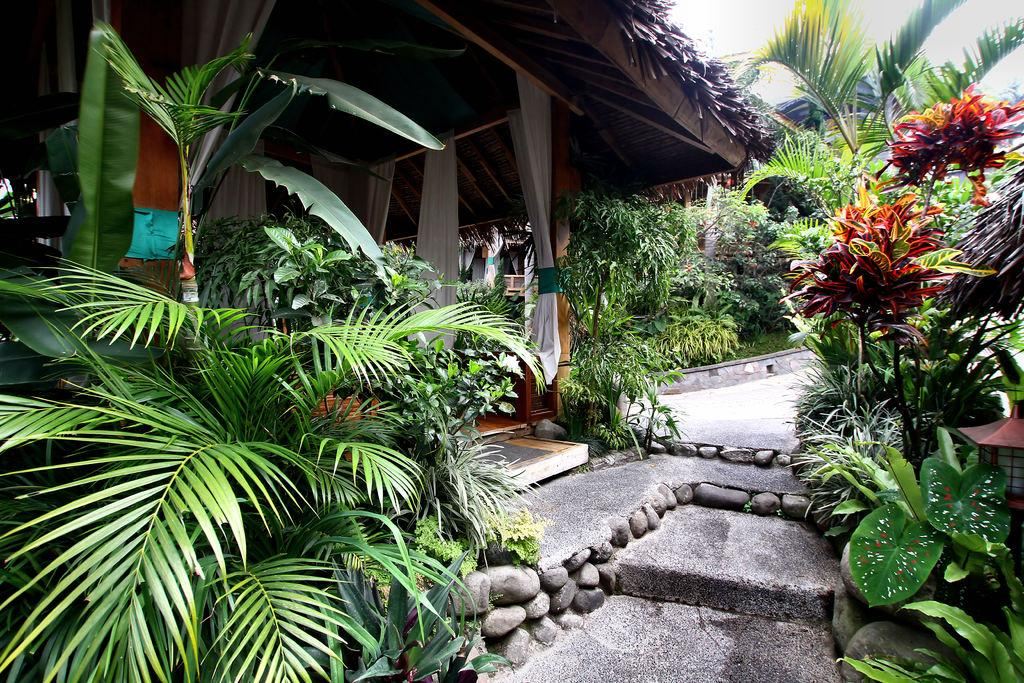What type of vegetation can be seen in the image? There are plants and trees in the image. What structures are present in the image? There are sheds in the image. What part of the natural environment is visible? The sky is visible in the top right corner of the image. What rule is being enforced by the quince in the image? There is no quince present in the image, and therefore no rule enforcement can be observed. How many bikes are parked near the sheds in the image? There is no mention of bikes in the image, so we cannot determine the number of bikes present. 